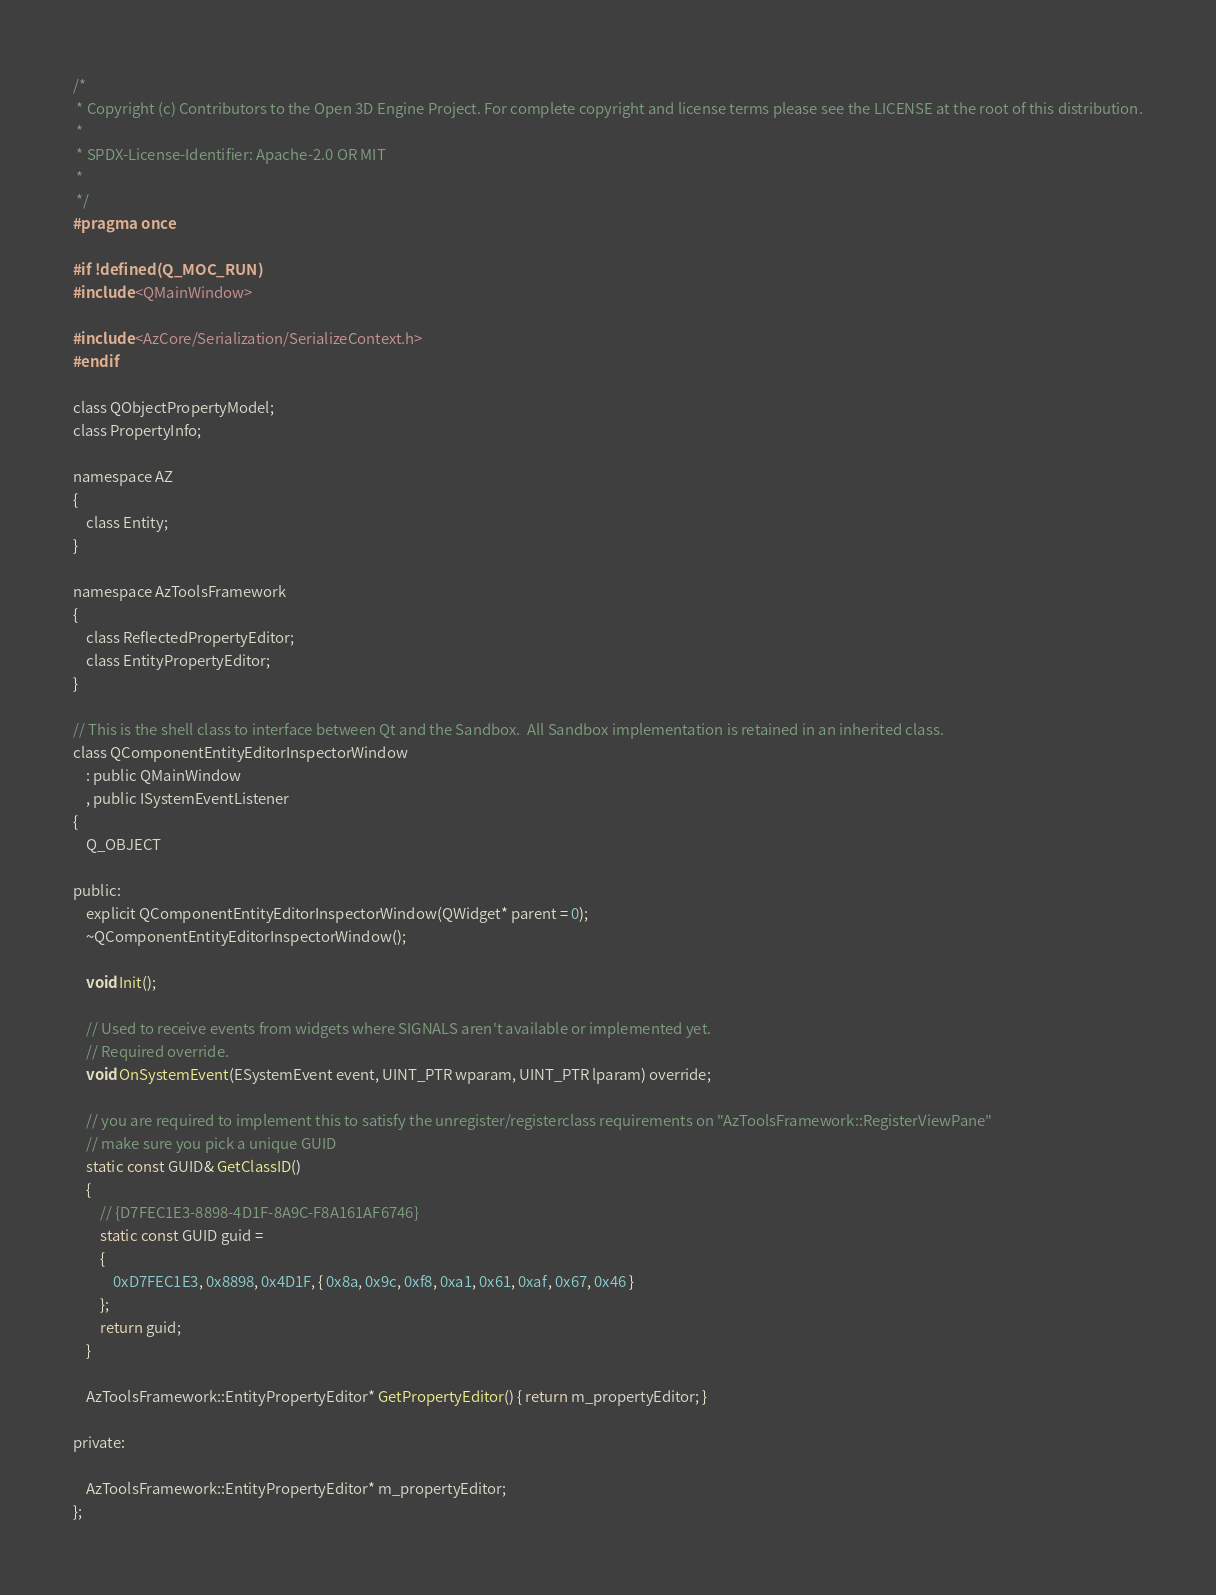<code> <loc_0><loc_0><loc_500><loc_500><_C_>/*
 * Copyright (c) Contributors to the Open 3D Engine Project. For complete copyright and license terms please see the LICENSE at the root of this distribution.
 * 
 * SPDX-License-Identifier: Apache-2.0 OR MIT
 *
 */
#pragma once

#if !defined(Q_MOC_RUN)
#include <QMainWindow>

#include <AzCore/Serialization/SerializeContext.h>
#endif

class QObjectPropertyModel;
class PropertyInfo;

namespace AZ
{
    class Entity;
}

namespace AzToolsFramework
{
    class ReflectedPropertyEditor;
    class EntityPropertyEditor;
}

// This is the shell class to interface between Qt and the Sandbox.  All Sandbox implementation is retained in an inherited class.
class QComponentEntityEditorInspectorWindow
    : public QMainWindow
    , public ISystemEventListener
{
    Q_OBJECT

public:
    explicit QComponentEntityEditorInspectorWindow(QWidget* parent = 0);
    ~QComponentEntityEditorInspectorWindow();

    void Init();

    // Used to receive events from widgets where SIGNALS aren't available or implemented yet.
    // Required override.
    void OnSystemEvent(ESystemEvent event, UINT_PTR wparam, UINT_PTR lparam) override;

    // you are required to implement this to satisfy the unregister/registerclass requirements on "AzToolsFramework::RegisterViewPane"
    // make sure you pick a unique GUID
    static const GUID& GetClassID()
    {
        // {D7FEC1E3-8898-4D1F-8A9C-F8A161AF6746}
        static const GUID guid =
        {
            0xD7FEC1E3, 0x8898, 0x4D1F, { 0x8a, 0x9c, 0xf8, 0xa1, 0x61, 0xaf, 0x67, 0x46 }
        };
        return guid;
    }

    AzToolsFramework::EntityPropertyEditor* GetPropertyEditor() { return m_propertyEditor; }

private:

    AzToolsFramework::EntityPropertyEditor* m_propertyEditor;
};
</code> 